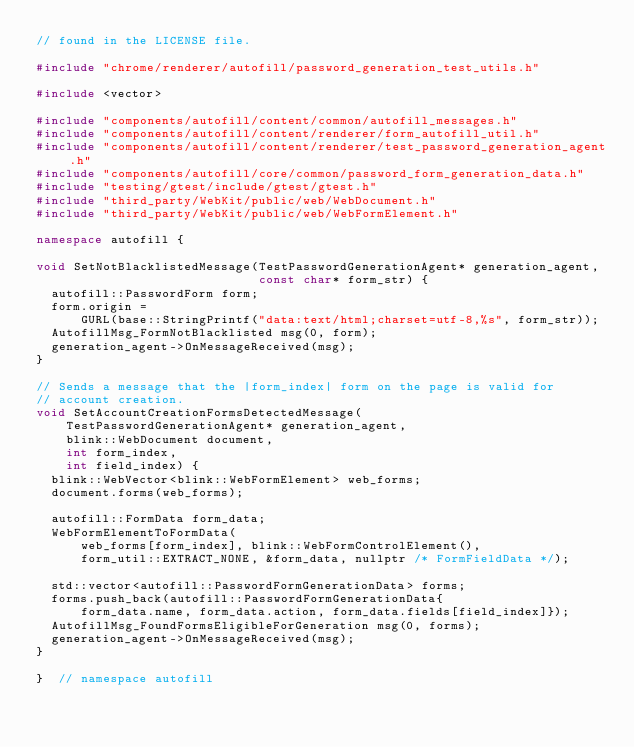<code> <loc_0><loc_0><loc_500><loc_500><_C++_>// found in the LICENSE file.

#include "chrome/renderer/autofill/password_generation_test_utils.h"

#include <vector>

#include "components/autofill/content/common/autofill_messages.h"
#include "components/autofill/content/renderer/form_autofill_util.h"
#include "components/autofill/content/renderer/test_password_generation_agent.h"
#include "components/autofill/core/common/password_form_generation_data.h"
#include "testing/gtest/include/gtest/gtest.h"
#include "third_party/WebKit/public/web/WebDocument.h"
#include "third_party/WebKit/public/web/WebFormElement.h"

namespace autofill {

void SetNotBlacklistedMessage(TestPasswordGenerationAgent* generation_agent,
                              const char* form_str) {
  autofill::PasswordForm form;
  form.origin =
      GURL(base::StringPrintf("data:text/html;charset=utf-8,%s", form_str));
  AutofillMsg_FormNotBlacklisted msg(0, form);
  generation_agent->OnMessageReceived(msg);
}

// Sends a message that the |form_index| form on the page is valid for
// account creation.
void SetAccountCreationFormsDetectedMessage(
    TestPasswordGenerationAgent* generation_agent,
    blink::WebDocument document,
    int form_index,
    int field_index) {
  blink::WebVector<blink::WebFormElement> web_forms;
  document.forms(web_forms);

  autofill::FormData form_data;
  WebFormElementToFormData(
      web_forms[form_index], blink::WebFormControlElement(),
      form_util::EXTRACT_NONE, &form_data, nullptr /* FormFieldData */);

  std::vector<autofill::PasswordFormGenerationData> forms;
  forms.push_back(autofill::PasswordFormGenerationData{
      form_data.name, form_data.action, form_data.fields[field_index]});
  AutofillMsg_FoundFormsEligibleForGeneration msg(0, forms);
  generation_agent->OnMessageReceived(msg);
}

}  // namespace autofill
</code> 